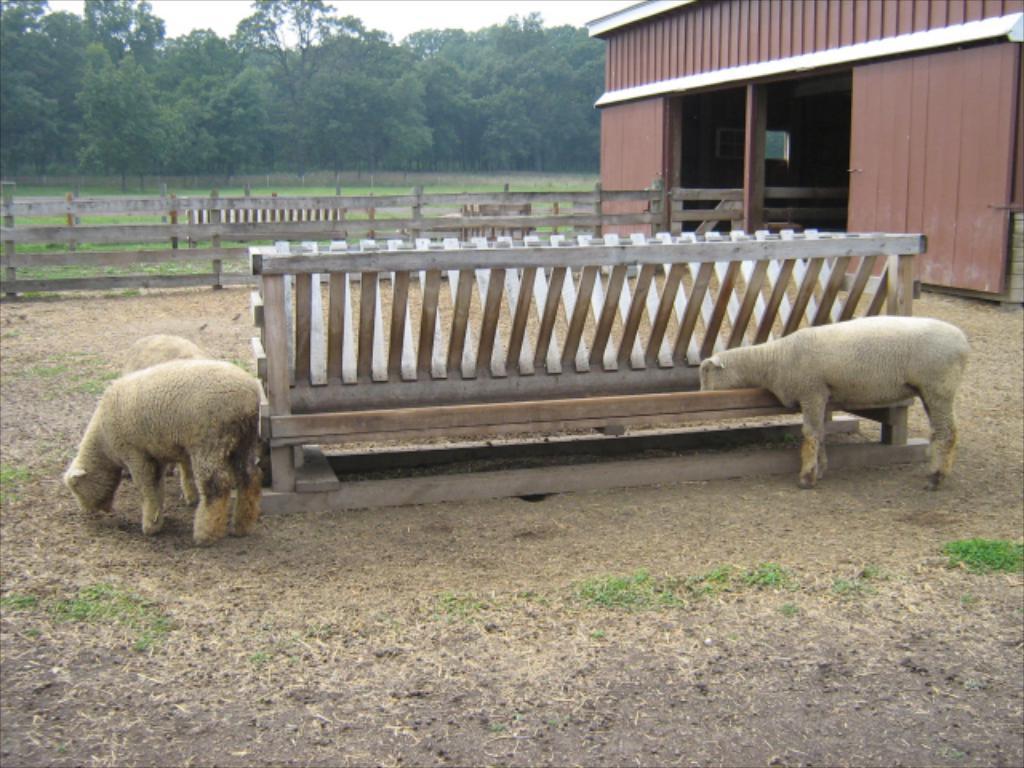In one or two sentences, can you explain what this image depicts? In this image I can see few animals, they are in brown and cream color. Background I can see a shed in brown color, wooden fencing, trees in green color and the sky is in white color. 